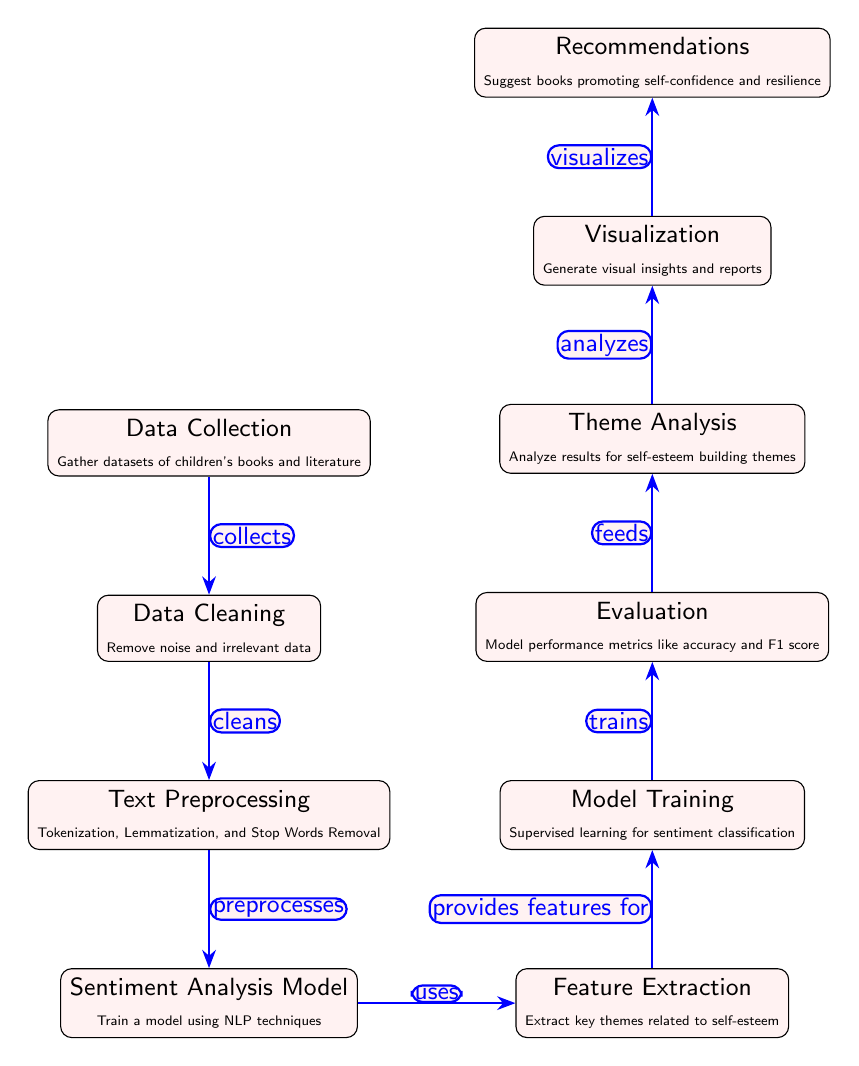What is the first step in the diagram? The first step in the diagram is "Data Collection," which involves gathering datasets of children's books and literature.
Answer: Data Collection How many nodes are in the diagram? By counting each labeled node in the diagram, there are a total of ten nodes present in the sequence.
Answer: Ten What process follows Data Cleaning? After Data Cleaning, the next process is Text Preprocessing, which includes tokenization, lemmatization, and stop words removal.
Answer: Text Preprocessing What is the purpose of the Sentiment Analysis Model? The purpose of the Sentiment Analysis Model is to train a model using NLP techniques to evaluate sentiment.
Answer: Train a model using NLP techniques Which step provides features for Model Training? The step that provides features for Model Training is Feature Extraction, which extracts key themes related to self-esteem.
Answer: Feature Extraction What does the Visualization node generate? The Visualization node generates visual insights and reports to help interpret the analysis results effectively.
Answer: Visual insights and reports What is the final output of the diagram? The final output of the diagram is Recommendations, which suggests books that promote self-confidence and resilience.
Answer: Recommendations Which two nodes does the arrow connecting Theme Analysis and Visualization represent? The arrow represents that Theme Analysis analyzes results for self-esteem building themes and feeds insights into Visualization for reporting purposes.
Answer: Analyzes and Visualizes What kind of learning is utilized in Model Training? The diagram specifies that Supervised learning is utilized for sentiment classification during the Model Training step.
Answer: Supervised learning 